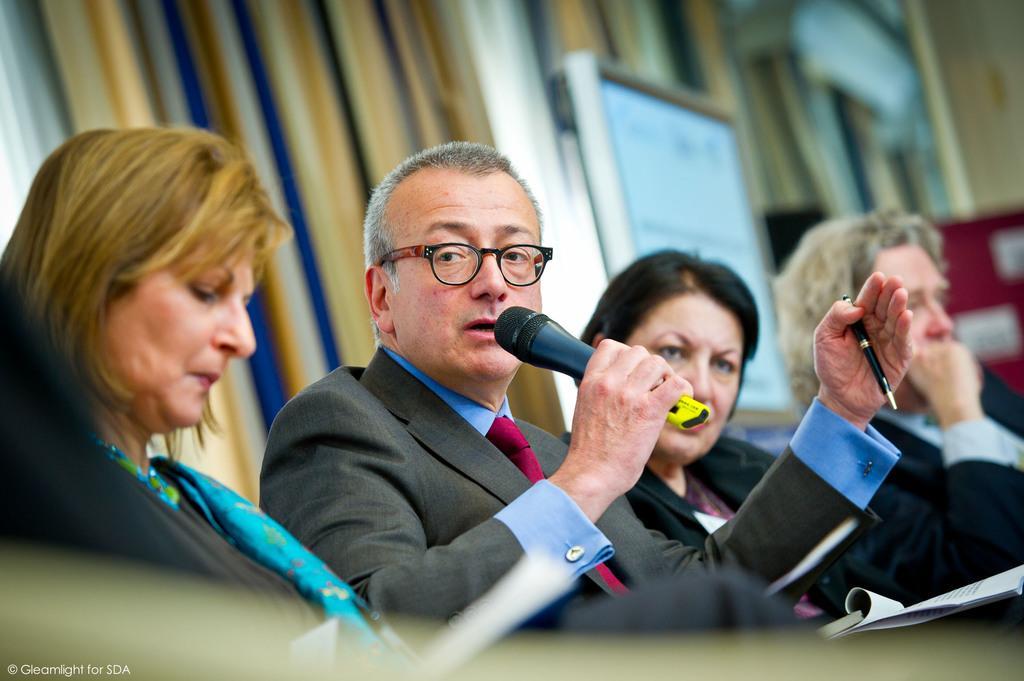Describe this image in one or two sentences. There is a man in the center of the image, by holding a mic and a pen in his hands and there are people on both the sides, it seems like there is a poster and curtains in the background. 